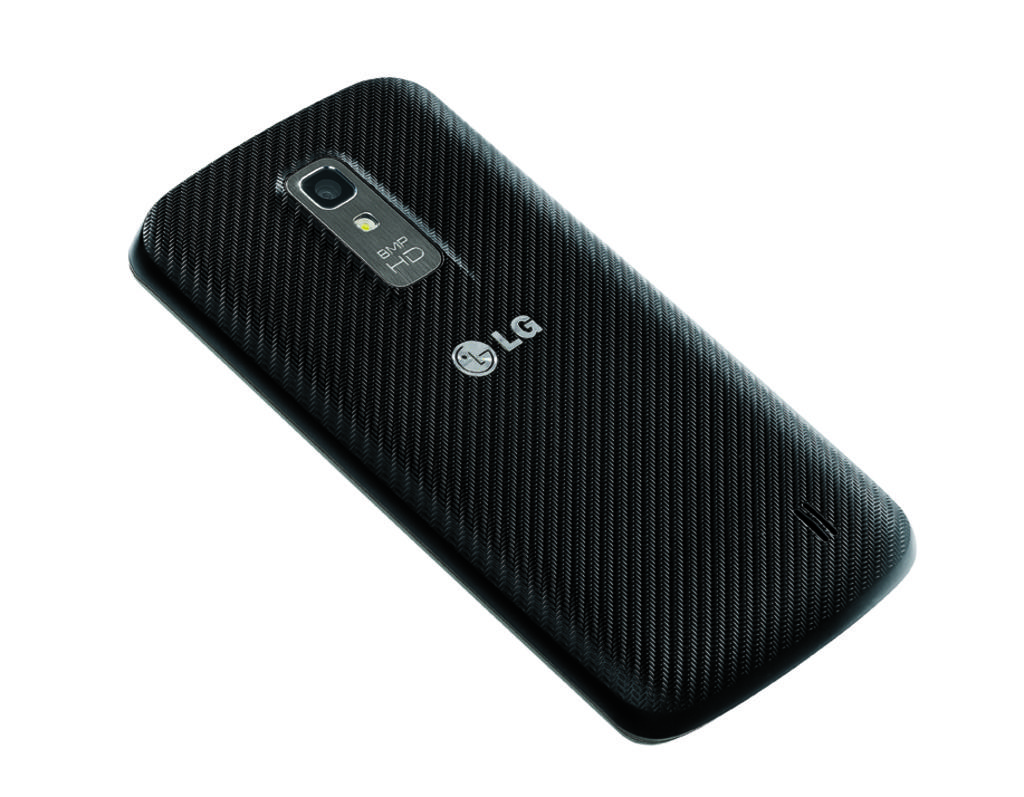What is the brand of this phone?
Ensure brevity in your answer.  Lg. Brand of this phone is lg?
Your answer should be compact. Yes. 